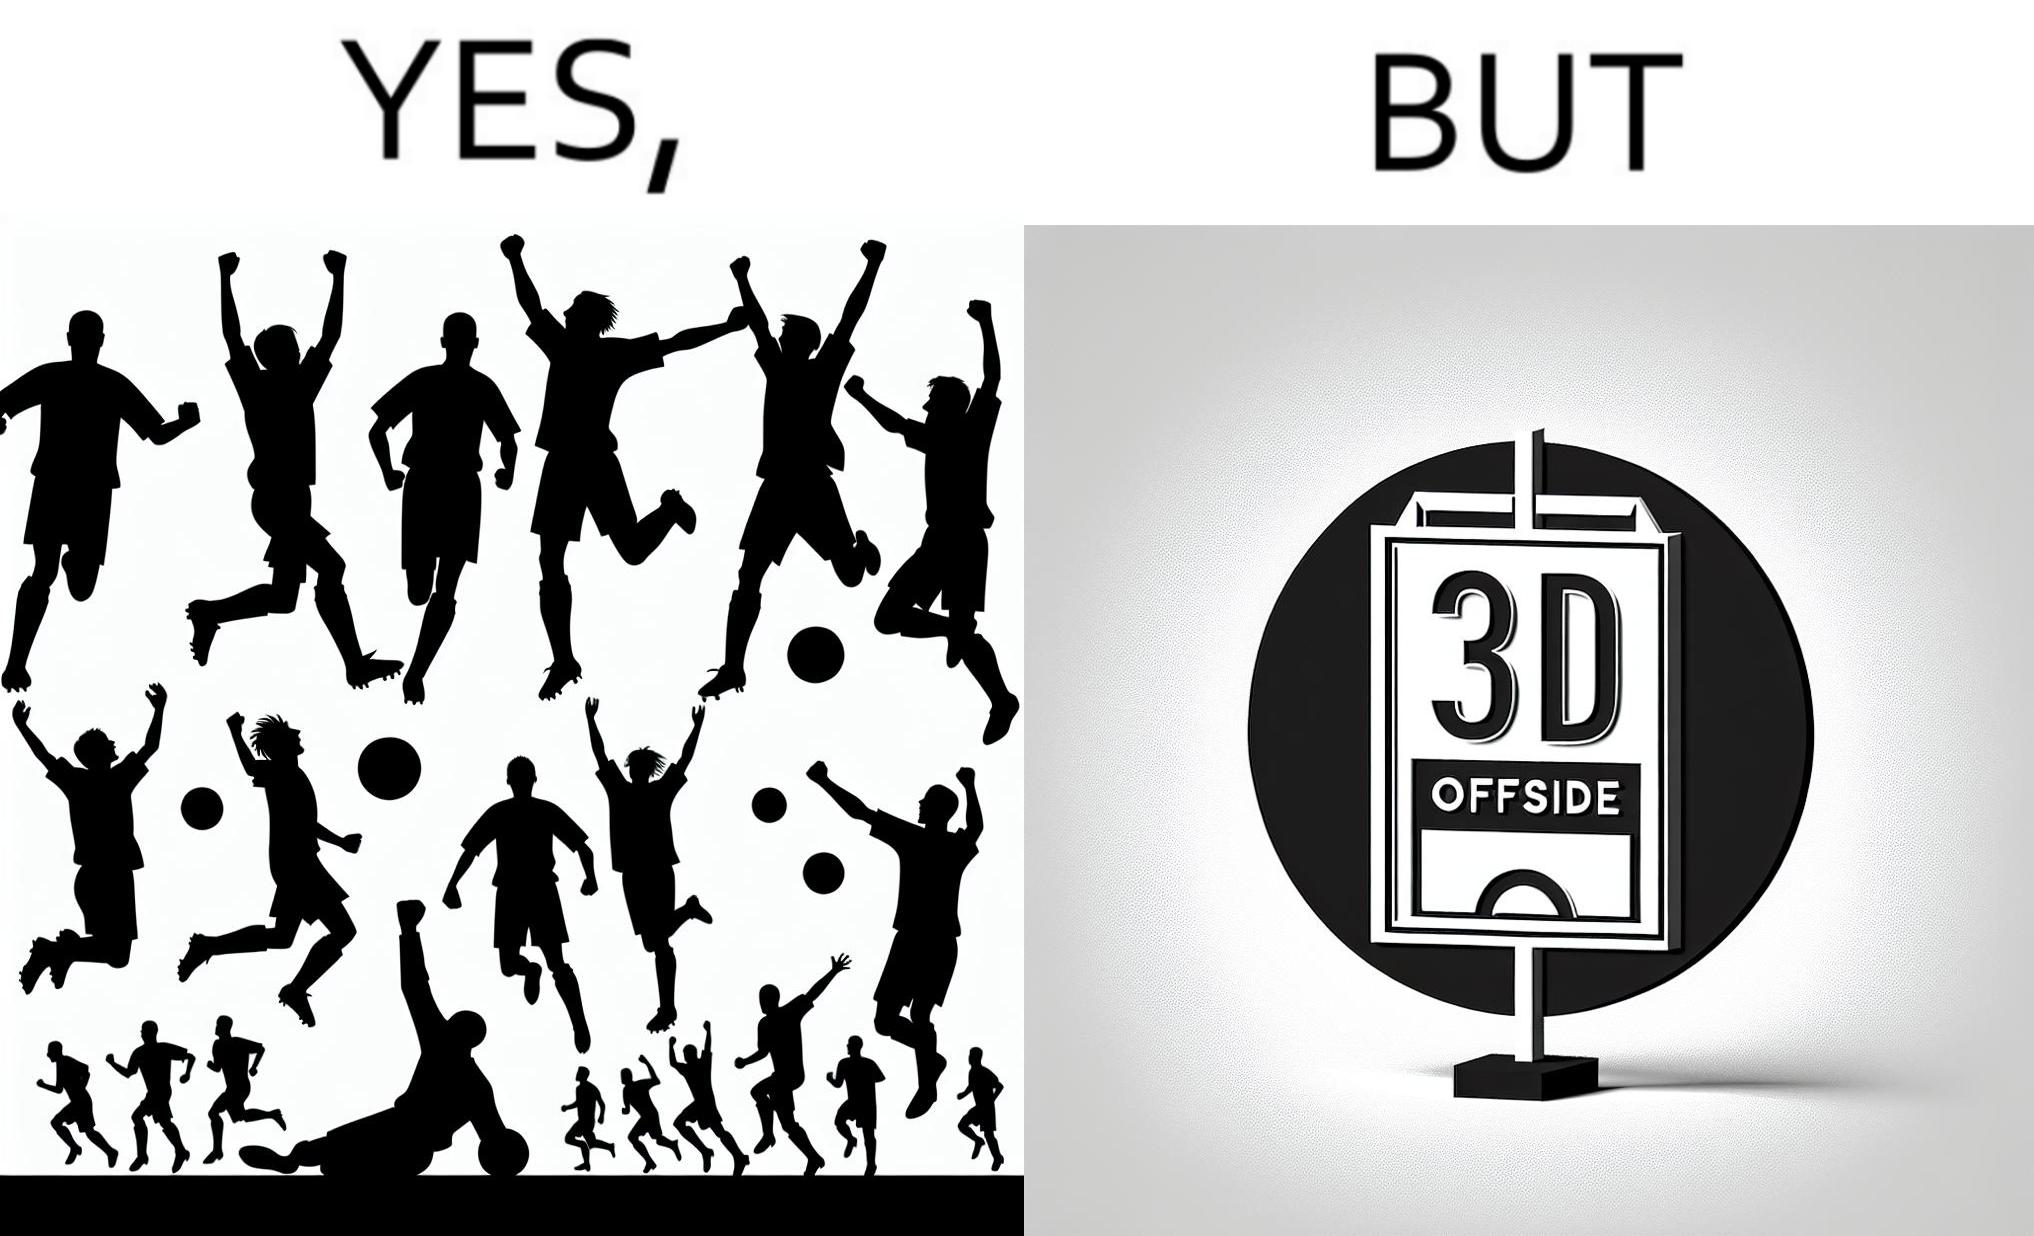Describe what you see in the left and right parts of this image. In the left part of the image: football players celebrating, probably due a goal their team has scored. In the right part of the image: A sign of "No goal - Offside". 